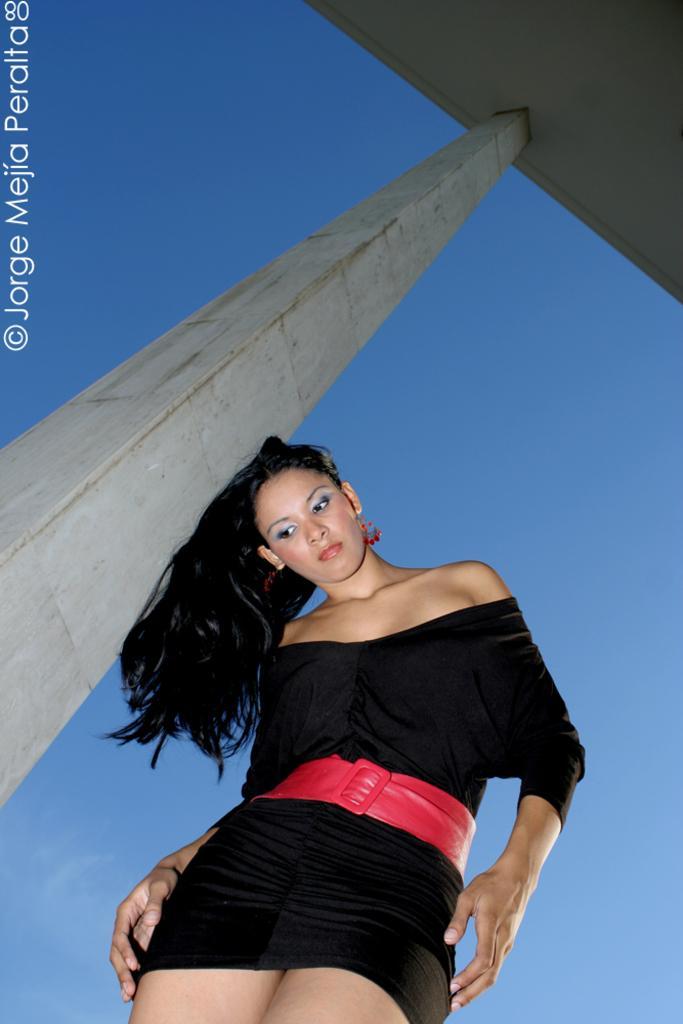How would you summarize this image in a sentence or two? In this picture I can see a woman in the middle, on the left side it looks like a pillar, there is the sky in the background. 